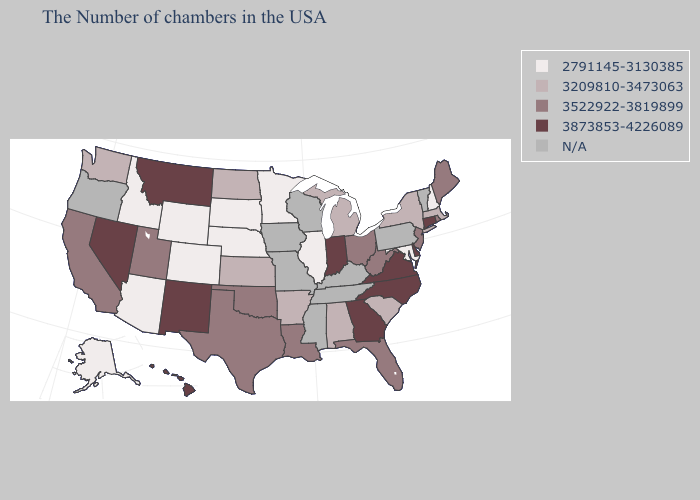What is the value of Delaware?
Be succinct. 3873853-4226089. What is the highest value in the South ?
Keep it brief. 3873853-4226089. Among the states that border New Mexico , which have the highest value?
Concise answer only. Oklahoma, Texas, Utah. What is the highest value in the USA?
Be succinct. 3873853-4226089. Among the states that border Iowa , which have the lowest value?
Write a very short answer. Illinois, Minnesota, Nebraska, South Dakota. What is the value of South Carolina?
Be succinct. 3209810-3473063. Does Rhode Island have the lowest value in the USA?
Short answer required. No. Does Connecticut have the lowest value in the USA?
Concise answer only. No. What is the lowest value in the USA?
Give a very brief answer. 2791145-3130385. What is the lowest value in states that border Arizona?
Short answer required. 2791145-3130385. Name the states that have a value in the range N/A?
Write a very short answer. Vermont, Pennsylvania, Kentucky, Tennessee, Wisconsin, Mississippi, Missouri, Iowa, Oregon. Does New Hampshire have the highest value in the Northeast?
Write a very short answer. No. Does Maryland have the lowest value in the South?
Answer briefly. Yes. What is the lowest value in states that border Arkansas?
Short answer required. 3522922-3819899. What is the value of Washington?
Be succinct. 3209810-3473063. 